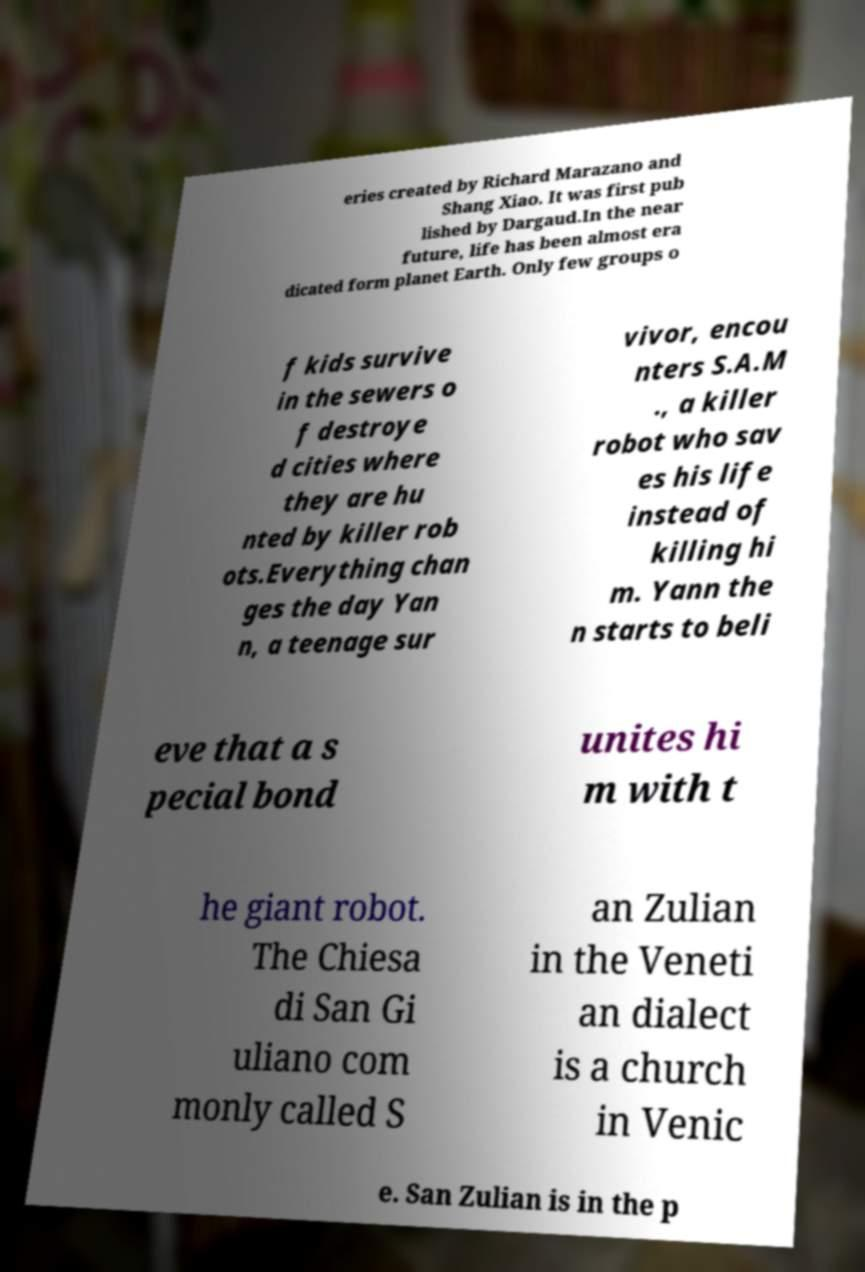Please read and relay the text visible in this image. What does it say? eries created by Richard Marazano and Shang Xiao. It was first pub lished by Dargaud.In the near future, life has been almost era dicated form planet Earth. Only few groups o f kids survive in the sewers o f destroye d cities where they are hu nted by killer rob ots.Everything chan ges the day Yan n, a teenage sur vivor, encou nters S.A.M ., a killer robot who sav es his life instead of killing hi m. Yann the n starts to beli eve that a s pecial bond unites hi m with t he giant robot. The Chiesa di San Gi uliano com monly called S an Zulian in the Veneti an dialect is a church in Venic e. San Zulian is in the p 